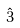Convert formula to latex. <formula><loc_0><loc_0><loc_500><loc_500>\hat { 3 }</formula> 